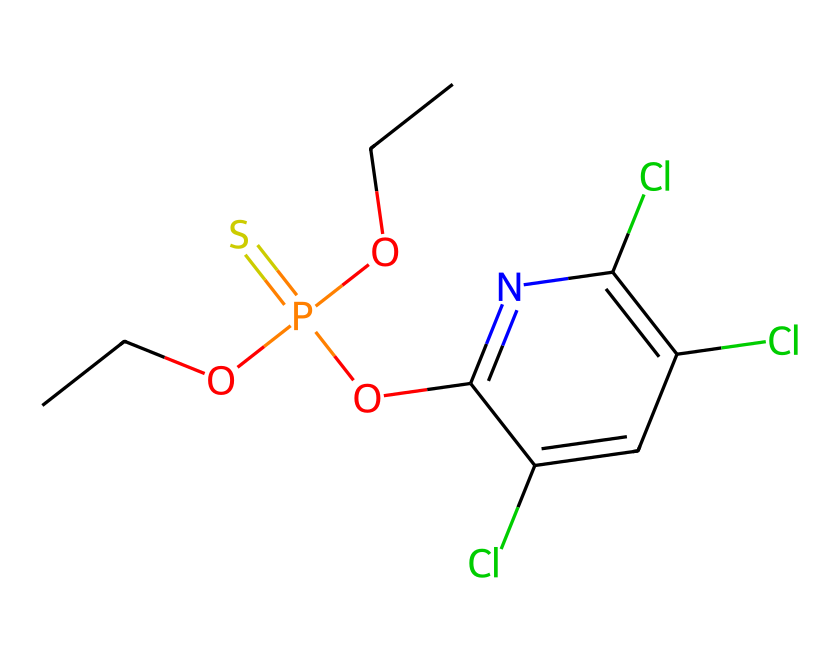What is the molecular formula of chlorpyrifos? To determine the molecular formula, count the number of each type of atom present in the SMILES representation. From the structure: there are 10 carbon (C) atoms, 12 hydrogen (H) atoms, 4 chlorine (Cl) atoms, 1 phosphorus (P) atom, and 1 oxygen (O) atom. Thus, the molecular formula is C10H10Cl3NO4PS.
Answer: C10H10Cl3NO4PS How many chlorine atoms are present in chlorpyrifos? In the SMILES representation, the presence of 'Cl' indicates chlorine atoms. Counting the occurrences, there are 3 instances of 'Cl' in the structure.
Answer: 3 What type of functional group is represented by 'P(=S)(OCC)'? The 'P(=S)(OCC)' part of the SMILES indicates a phosphorus atom double-bonded to sulfur and bonded to an ethoxy group (OCC). This indicates that it is a phosphorothioate functional group, which is typical in certain organophosphate pesticides.
Answer: phosphorothioate How many oxygen atoms are present in the chlorpyrifos structure? In the SMILES, there are two occurrences of 'O': one is part of the phosphorothioate group and the other as part of 'Oc1'. Count them to find a total of 4 oxygen atoms in the structure.
Answer: 4 What is the likely effect of the chlorine atoms on chemical reactivity? Chlorine atoms in organic compounds often increase the compound's hydrophobicity and can impact its biological activity, making it more persistent and potentially more toxic. This is common in pesticide mechanisms.
Answer: increase persistence Which part of chlorpyrifos structure contributes to its role as a pesticide? The presence of the phosphorus atom (P) in conjunction with sulfur (S) in the phosphorothioate functional group emphasizes its action as a neurotoxic pesticide. This structure inhibits acetylcholinesterase, a key enzyme in nerve function.
Answer: phosphorothioate group Does chlorpyrifos have any double bonds? Yes, the '=' sign in the SMILES indicates that there is a double bond between phosphorus and sulfur, and between the oxygen and phosphorus as well, showing the presence of double bonds in the molecule.
Answer: Yes 